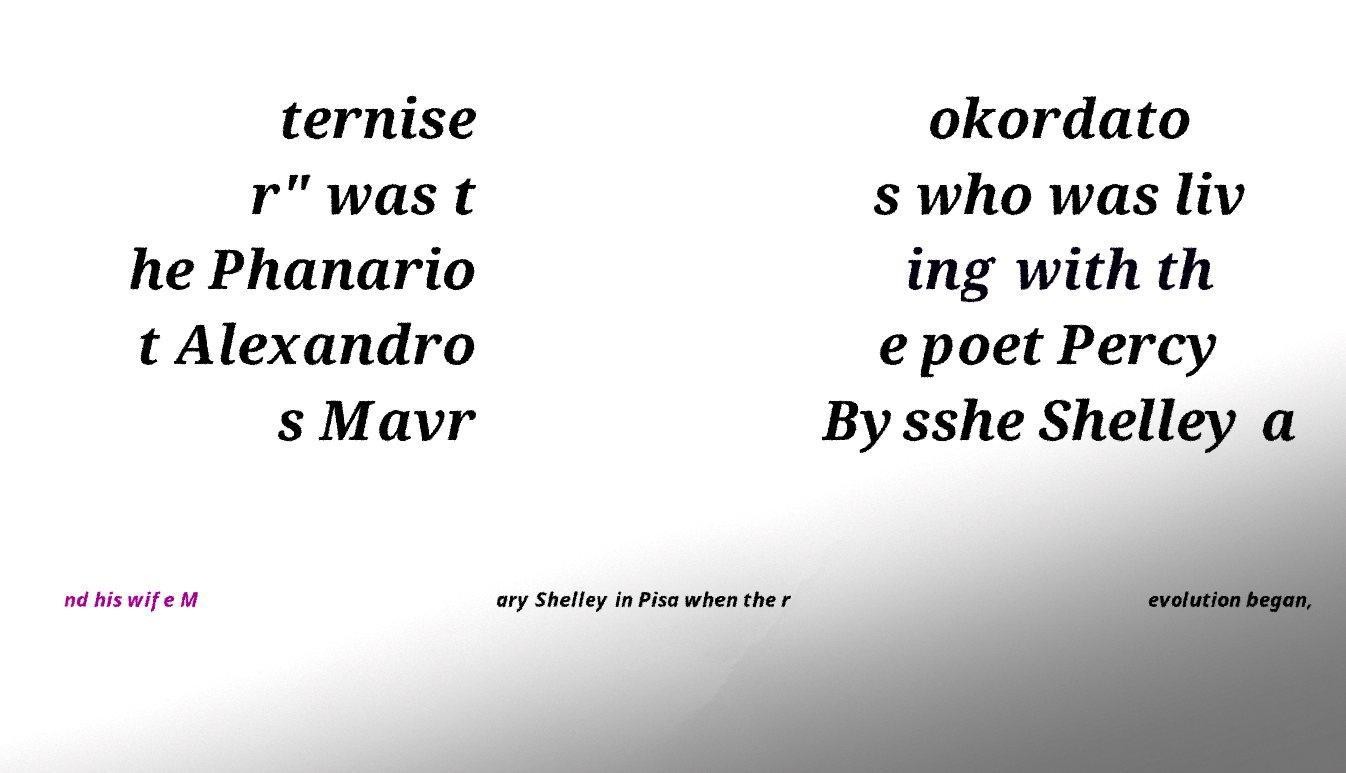Please read and relay the text visible in this image. What does it say? ternise r" was t he Phanario t Alexandro s Mavr okordato s who was liv ing with th e poet Percy Bysshe Shelley a nd his wife M ary Shelley in Pisa when the r evolution began, 